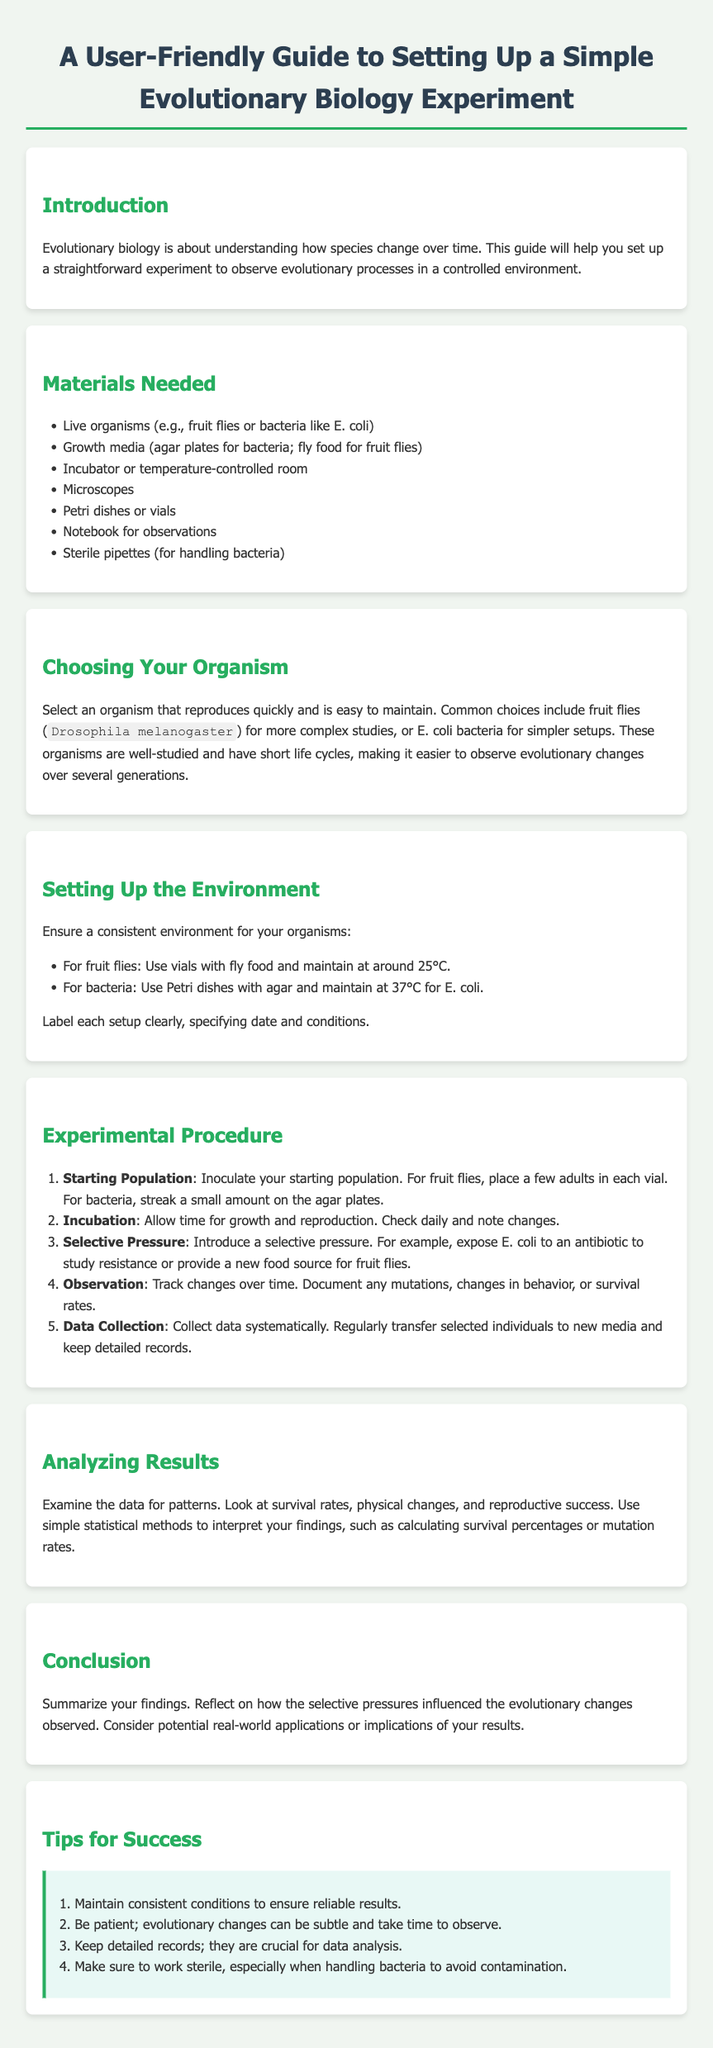What is the purpose of evolutionary biology? The purpose is to understand how species change over time.
Answer: Understand how species change over time What organism is recommended for simpler setups? The document suggests a choice between fruit flies and E. coli, specifically stating E. coli for simpler setups.
Answer: E. coli What temperature should be maintained for studying E. coli? The recommended temperature for E. coli is mentioned to be 37°C.
Answer: 37°C How many steps are in the experimental procedure? The document outlines five steps in the experimental procedure.
Answer: Five What should you track during the observation step? The key points to document include mutations, changes in behavior, or survival rates.
Answer: Mutations, changes in behavior, or survival rates What is one tip for success mentioned in the guide? The guide provides several tips; one is to maintain consistent conditions for reliable results.
Answer: Maintain consistent conditions 